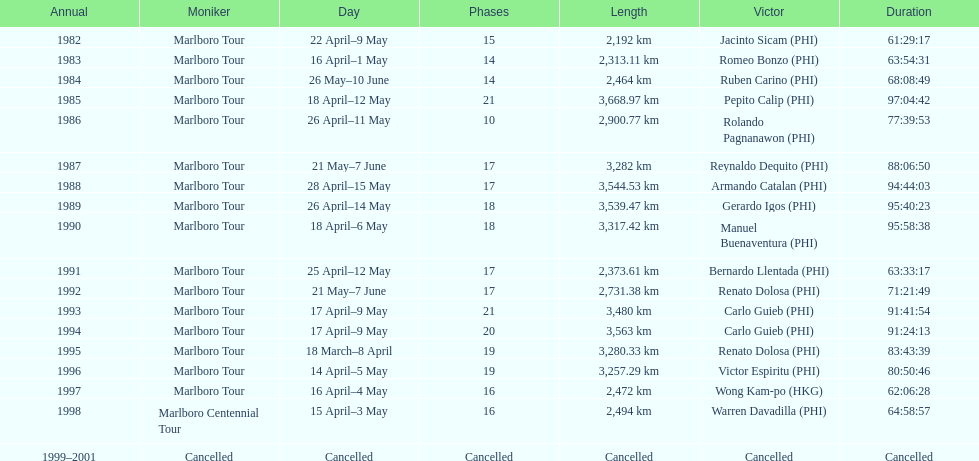Who is listed below romeo bonzo? Ruben Carino (PHI). 